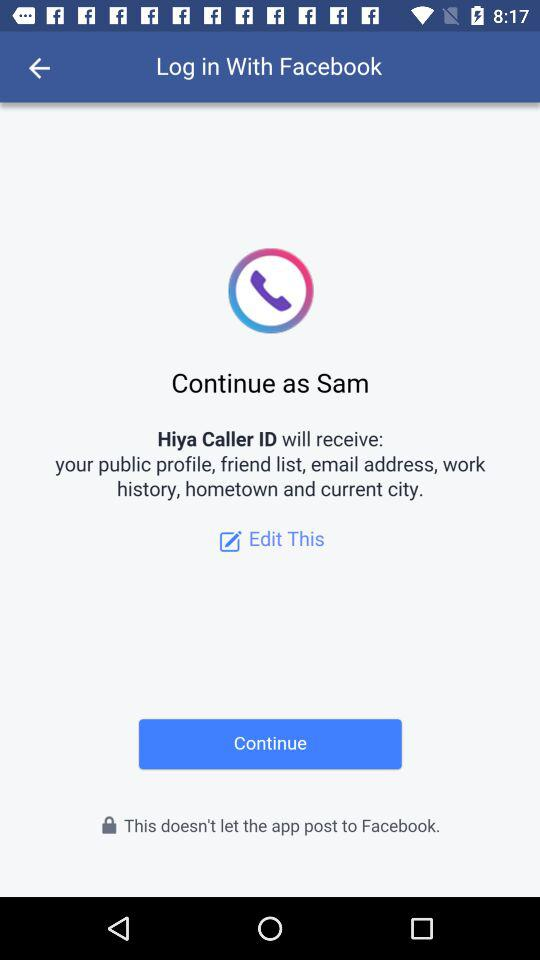What application is asking for permission? The application asking for permission is "Hiya Caller ID". 